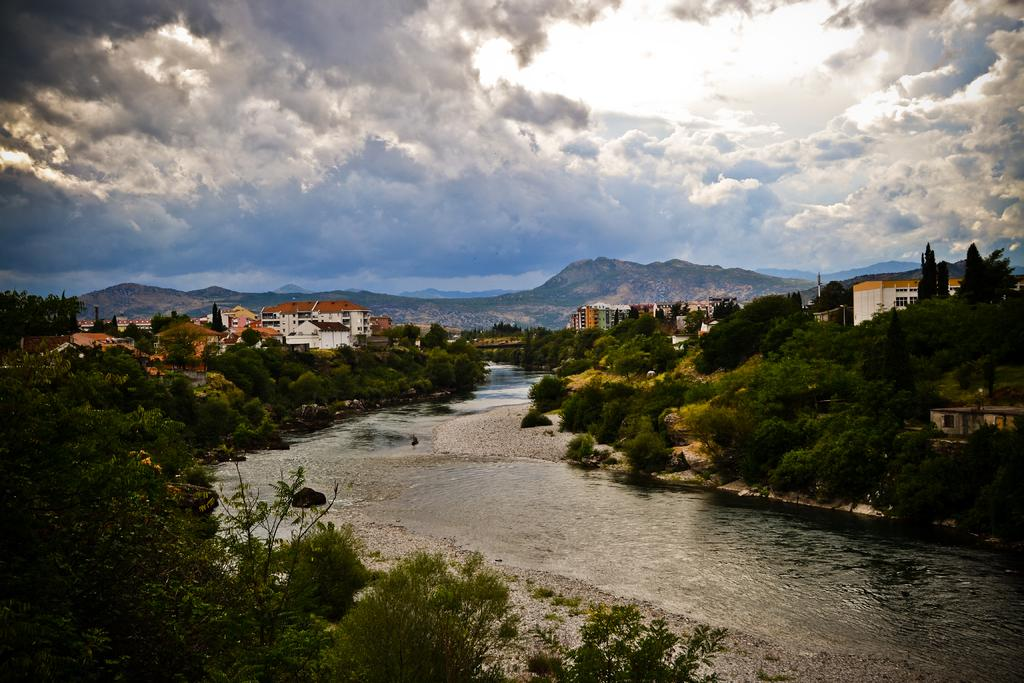What natural feature is the main subject of the image? There is a river in the image. What type of vegetation is present near the river? Trees are present on both sides of the river. What can be seen in the distance in the image? There are mountains and buildings in the background of the image. What is the condition of the sky in the image? The sky is covered with clouds. What type of gold can be seen coming out of the chimney of the buildings in the image? There is no gold or chimney visible in the image; the buildings are in the background, and the image does not show any smoke or gold coming out of them. 